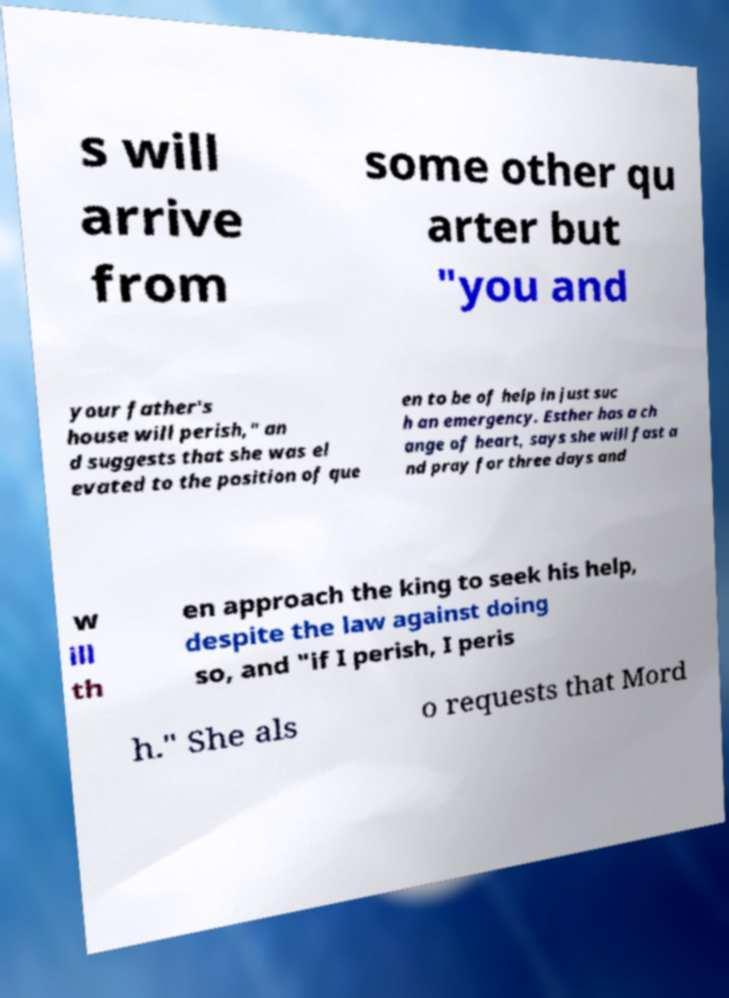Could you assist in decoding the text presented in this image and type it out clearly? s will arrive from some other qu arter but "you and your father's house will perish," an d suggests that she was el evated to the position of que en to be of help in just suc h an emergency. Esther has a ch ange of heart, says she will fast a nd pray for three days and w ill th en approach the king to seek his help, despite the law against doing so, and "if I perish, I peris h." She als o requests that Mord 